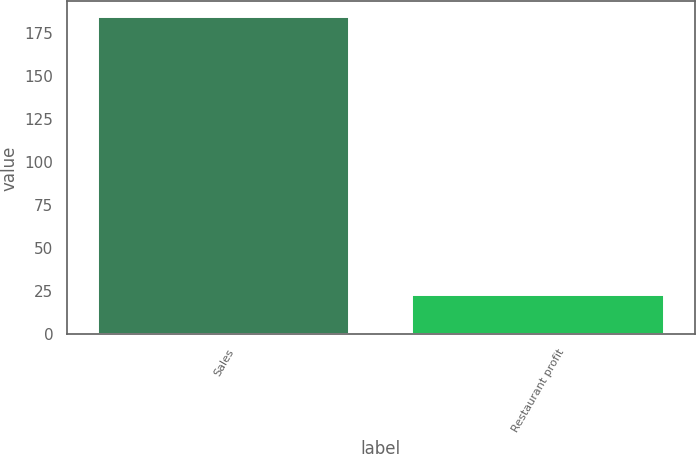Convert chart. <chart><loc_0><loc_0><loc_500><loc_500><bar_chart><fcel>Sales<fcel>Restaurant profit<nl><fcel>184<fcel>23<nl></chart> 